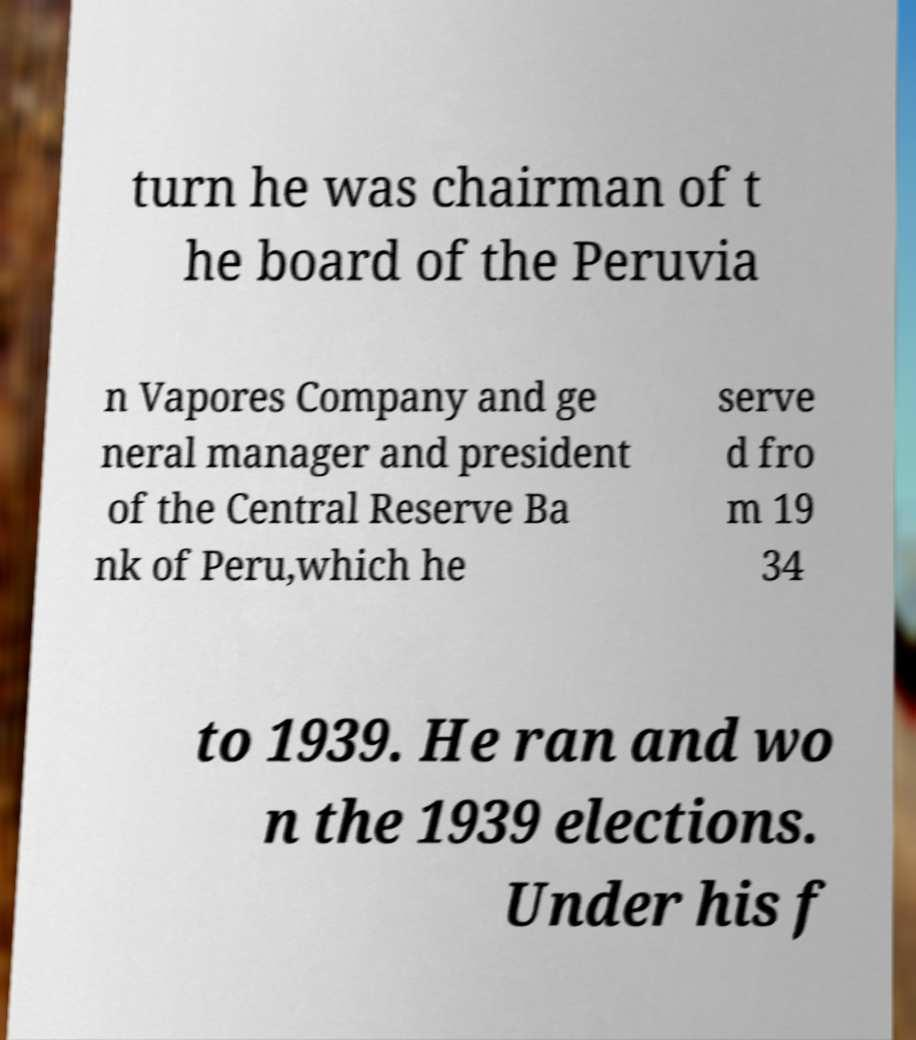I need the written content from this picture converted into text. Can you do that? turn he was chairman of t he board of the Peruvia n Vapores Company and ge neral manager and president of the Central Reserve Ba nk of Peru,which he serve d fro m 19 34 to 1939. He ran and wo n the 1939 elections. Under his f 